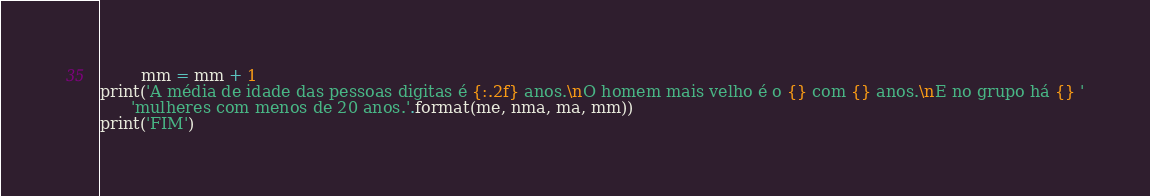<code> <loc_0><loc_0><loc_500><loc_500><_Python_>        mm = mm + 1
print('A média de idade das pessoas digitas é {:.2f} anos.\nO homem mais velho é o {} com {} anos.\nE no grupo há {} '
      'mulheres com menos de 20 anos.'.format(me, nma, ma, mm))
print('FIM')
</code> 